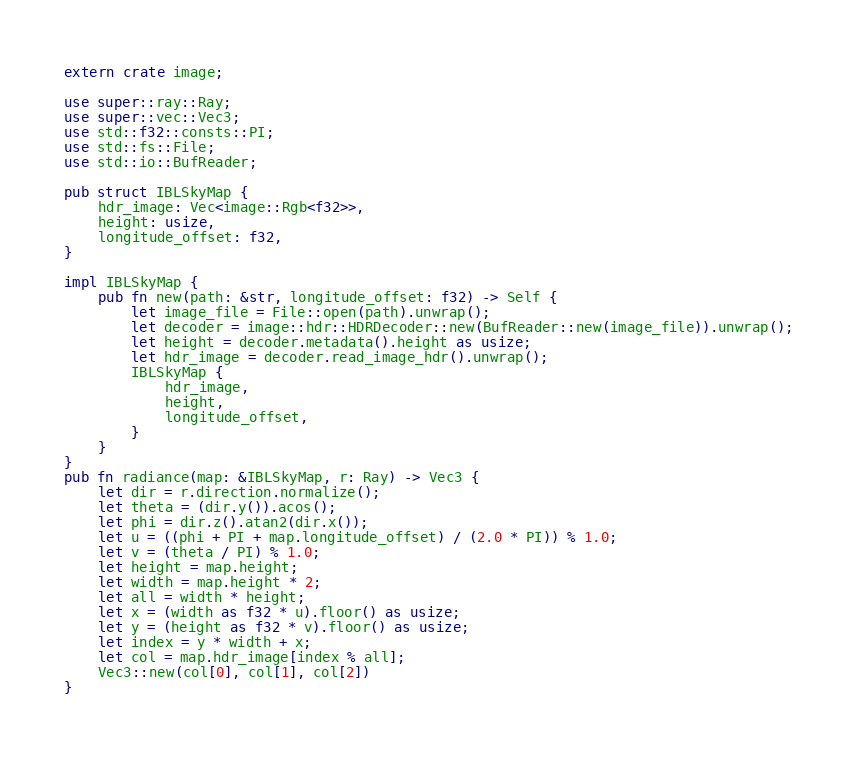<code> <loc_0><loc_0><loc_500><loc_500><_Rust_>extern crate image;

use super::ray::Ray;
use super::vec::Vec3;
use std::f32::consts::PI;
use std::fs::File;
use std::io::BufReader;

pub struct IBLSkyMap {
    hdr_image: Vec<image::Rgb<f32>>,
    height: usize,
    longitude_offset: f32,
}

impl IBLSkyMap {
    pub fn new(path: &str, longitude_offset: f32) -> Self {
        let image_file = File::open(path).unwrap();
        let decoder = image::hdr::HDRDecoder::new(BufReader::new(image_file)).unwrap();
        let height = decoder.metadata().height as usize;
        let hdr_image = decoder.read_image_hdr().unwrap();
        IBLSkyMap {
            hdr_image,
            height,
            longitude_offset,
        }
    }
}
pub fn radiance(map: &IBLSkyMap, r: Ray) -> Vec3 {
    let dir = r.direction.normalize();
    let theta = (dir.y()).acos();
    let phi = dir.z().atan2(dir.x());
    let u = ((phi + PI + map.longitude_offset) / (2.0 * PI)) % 1.0;
    let v = (theta / PI) % 1.0;
    let height = map.height;
    let width = map.height * 2;
    let all = width * height;
    let x = (width as f32 * u).floor() as usize;
    let y = (height as f32 * v).floor() as usize;
    let index = y * width + x;
    let col = map.hdr_image[index % all];
    Vec3::new(col[0], col[1], col[2])
}
</code> 